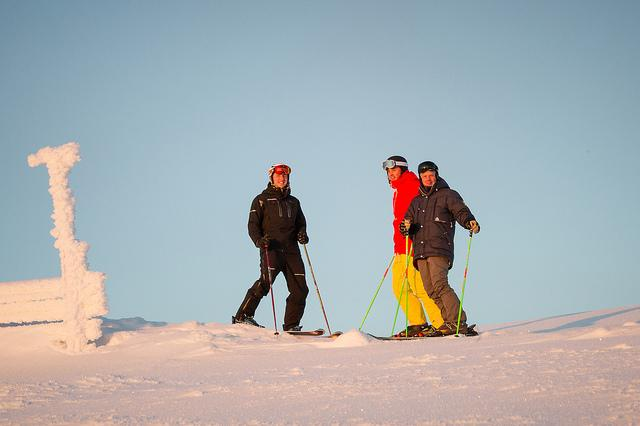Where will these men go next? Please explain your reasoning. down hill. The men will go down. 